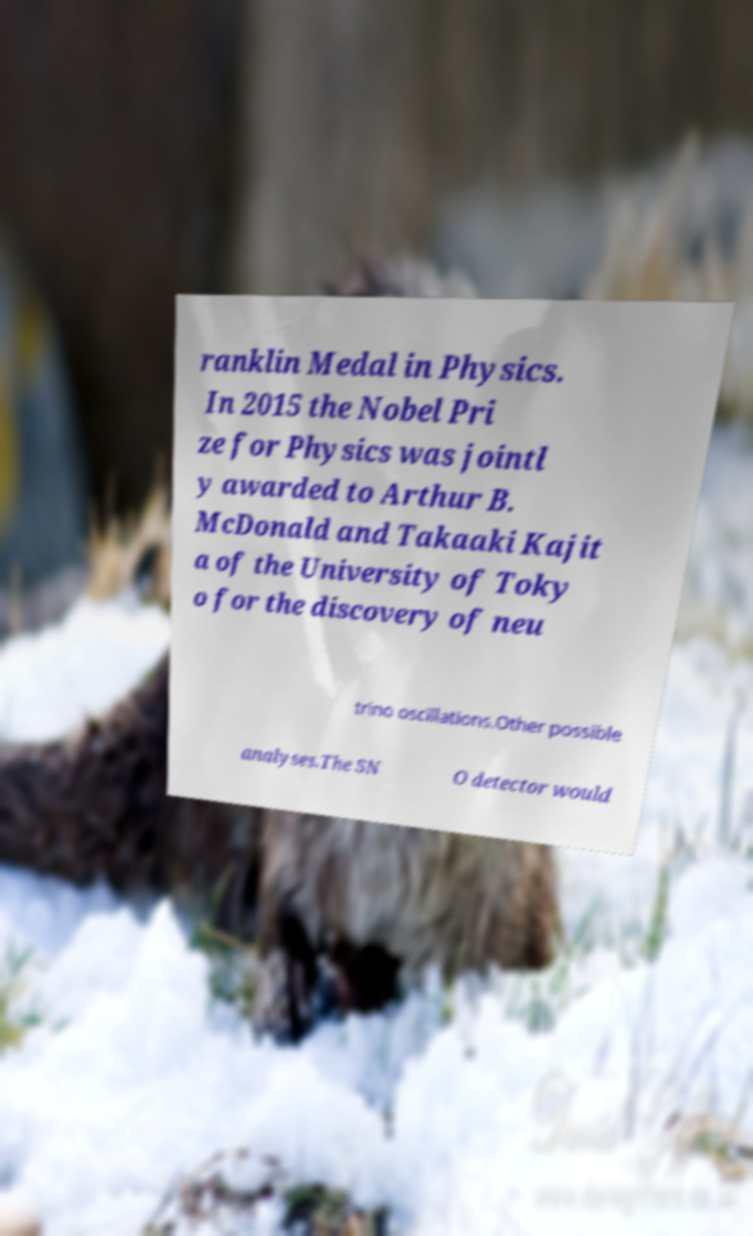Could you extract and type out the text from this image? ranklin Medal in Physics. In 2015 the Nobel Pri ze for Physics was jointl y awarded to Arthur B. McDonald and Takaaki Kajit a of the University of Toky o for the discovery of neu trino oscillations.Other possible analyses.The SN O detector would 